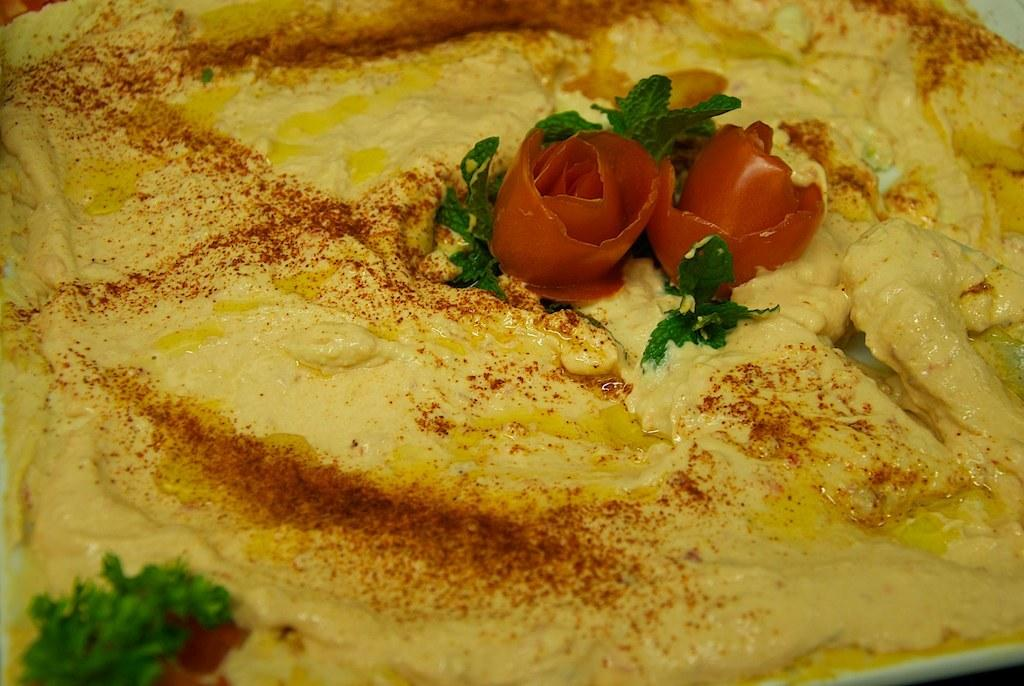What type of dish is featured in the image? There is an omelette in the image. How is the omelette decorated or garnished? The omelette is garnished with chili powder, tomato slices, and mint leaves. Are there any children swimming in the image? There is no reference to children or swimming in the image; it features an omelette with garnishes. 